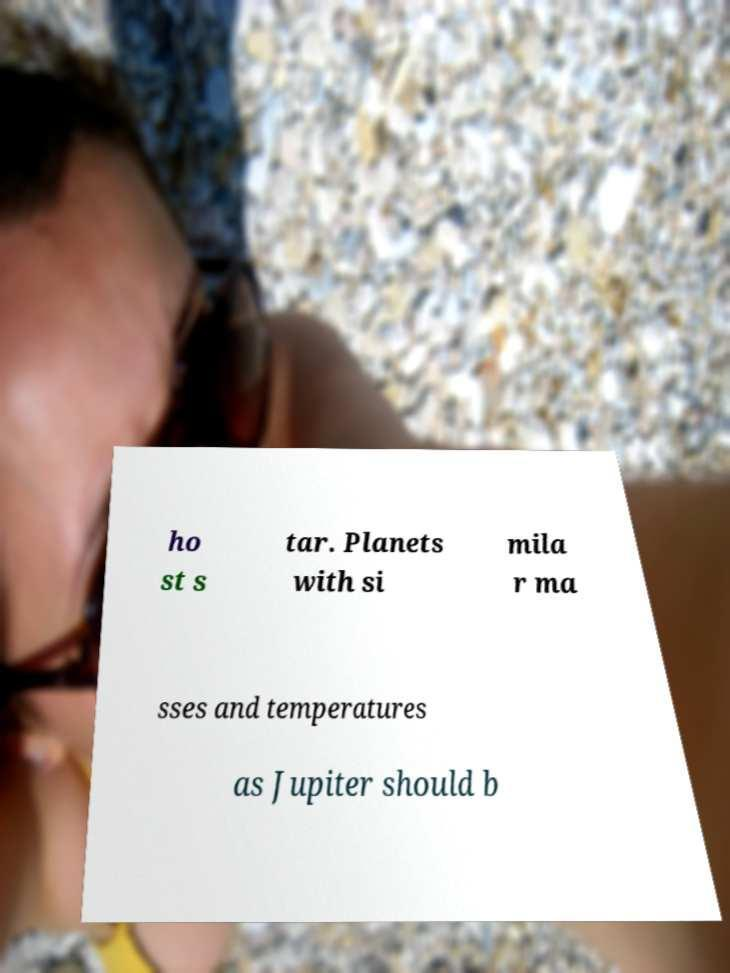What messages or text are displayed in this image? I need them in a readable, typed format. ho st s tar. Planets with si mila r ma sses and temperatures as Jupiter should b 